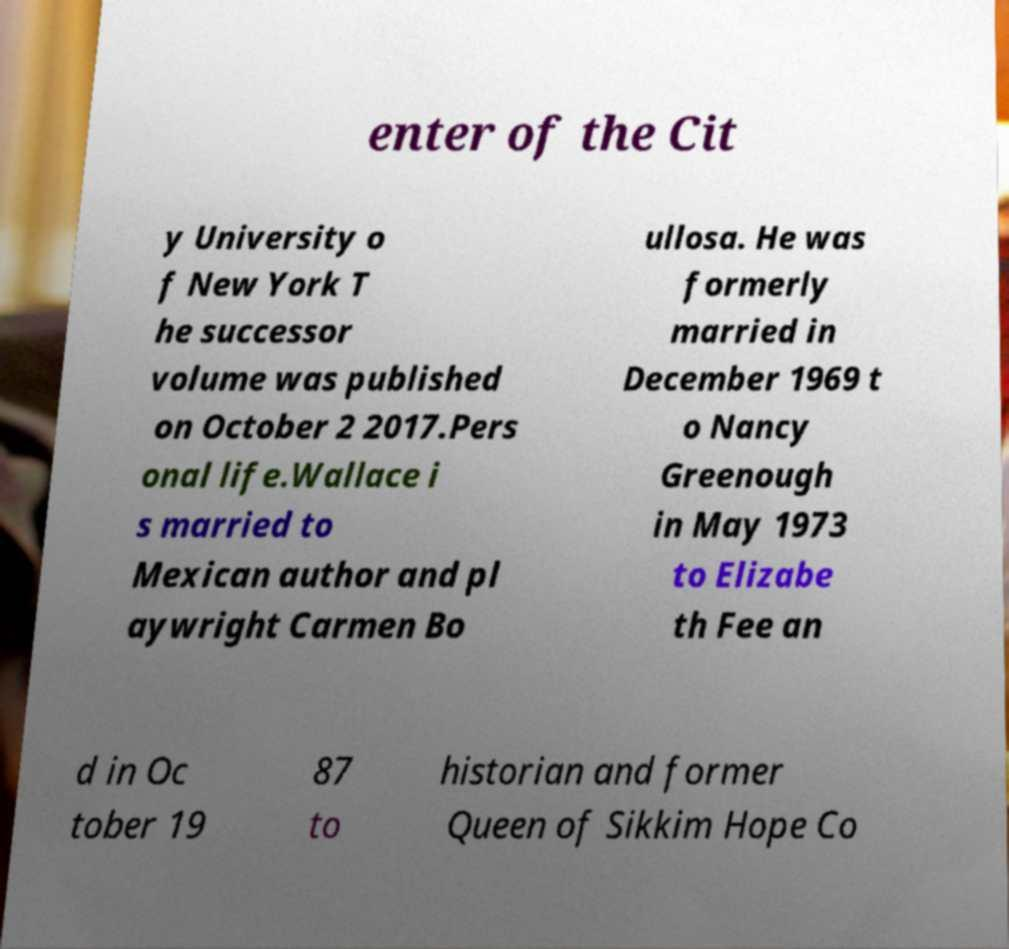Can you accurately transcribe the text from the provided image for me? enter of the Cit y University o f New York T he successor volume was published on October 2 2017.Pers onal life.Wallace i s married to Mexican author and pl aywright Carmen Bo ullosa. He was formerly married in December 1969 t o Nancy Greenough in May 1973 to Elizabe th Fee an d in Oc tober 19 87 to historian and former Queen of Sikkim Hope Co 